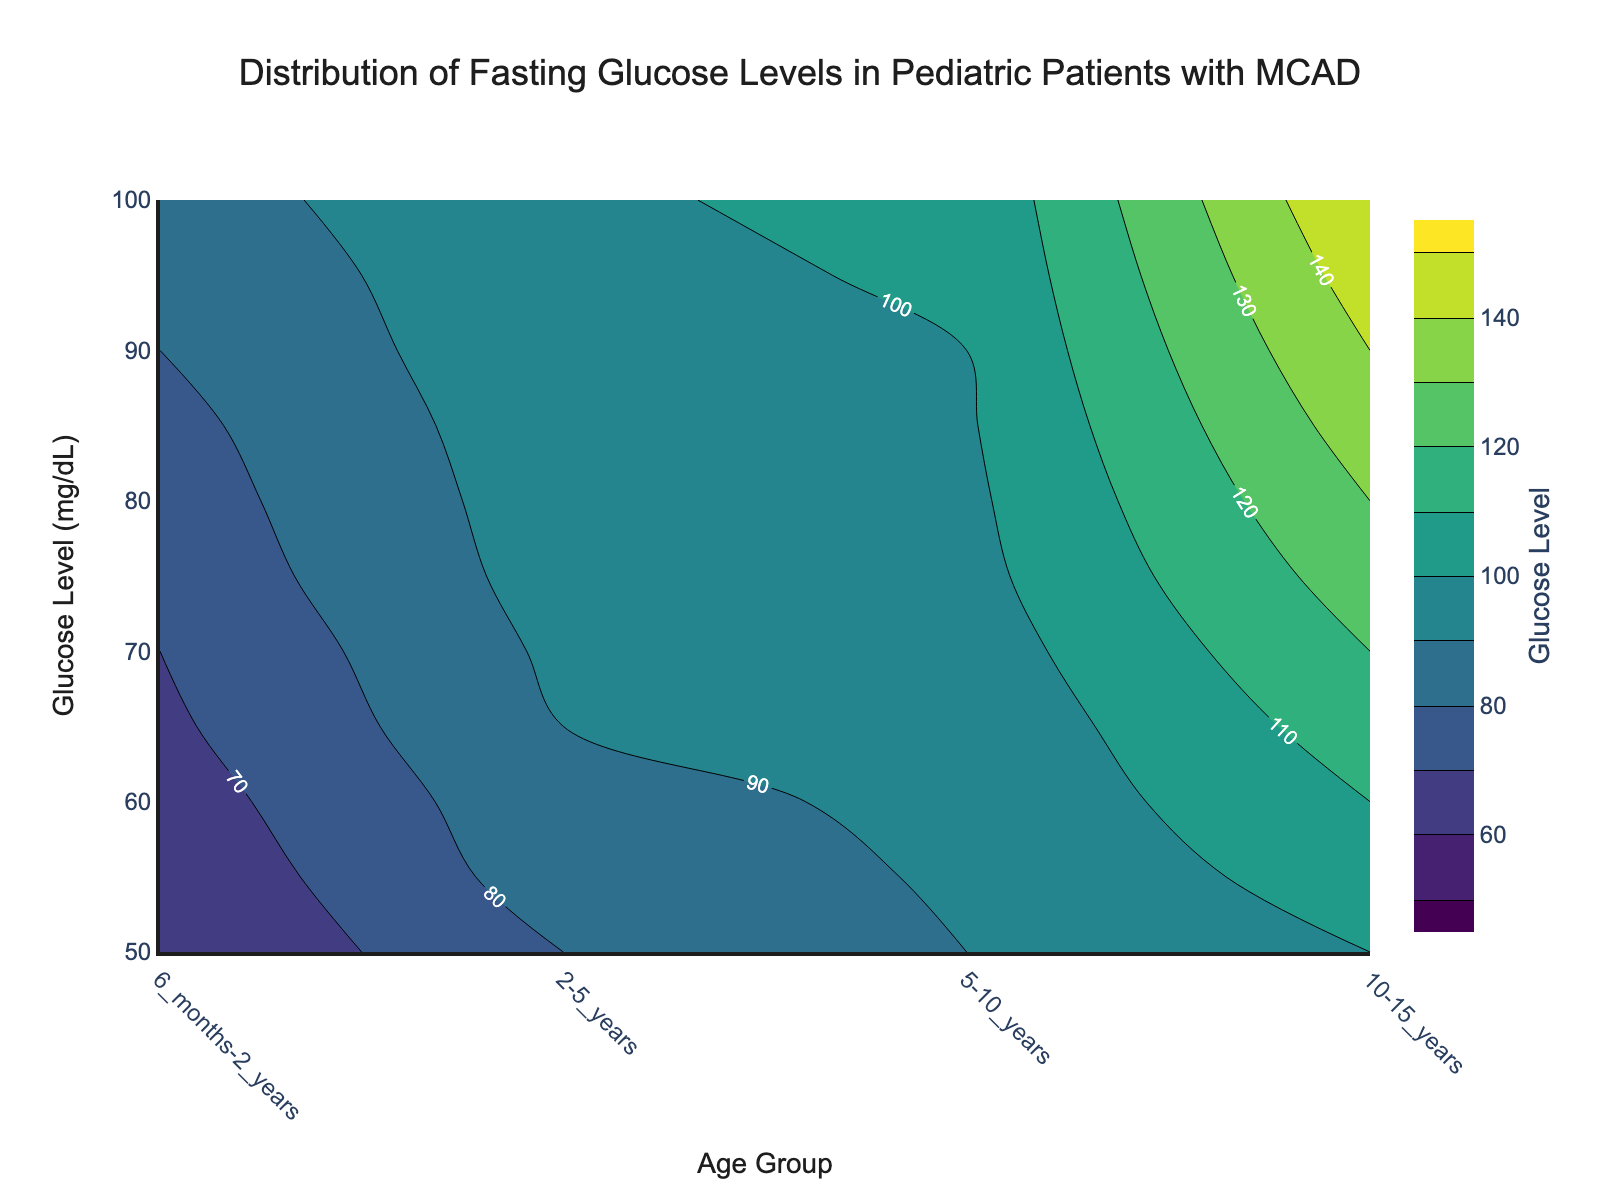What is the title of the figure? The title of the figure is displayed at the top and reads, "Distribution of Fasting Glucose Levels in Pediatric Patients with MCAD".
Answer: Distribution of Fasting Glucose Levels in Pediatric Patients with MCAD What color scale is used in the contour plot? The plot uses the 'Viridis' color scale, which ranges from dark purple to yellow-green.
Answer: Viridis Which age group shows the highest fasting glucose levels? Look at the contour lines and the color intensity across the age groups. The darkest yellowish-green indicates the highest glucose levels, which appears in the "10-15 years" age group.
Answer: 10-15 years What is the range of the fasting glucose levels plotted on the y-axis? The y-axis shows the glucose levels. It starts at 50 mg/dL and goes up to 150 mg/dL.
Answer: 50 to 150 mg/dL At what age group does the fasting glucose level first reach 100 mg/dL? Observe the contour lines and their corresponding labels. The 100 mg/dL contour line starts appearing in the "2-5 years" age group.
Answer: 2-5 years How does the fasting glucose level change as the age group increases from 6 months to 15 years? Trace the contour lines from left to right. As the age group increases, the glucose levels generally increase from 50 mg/dL to 150 mg/dL.
Answer: It increases Compare the glucose levels between the "6 months-2 years" and "5-10 years" age groups. Which one is higher and by how much? Identify the contour lines for both age groups. The "5-10 years" age group has higher glucose levels, ranging from 80 mg/dL to 99 mg/dL, compared to 50 mg/dL to 85 mg/dL for "6 months-2 years". The maximum difference is 99 - 85 = 14 mg/dL.
Answer: "5-10 years" is higher by up to 14 mg/dL What is the average fasting glucose level in the "10-15 years" age group based on the contour labels? Identify the glucose levels in the "10-15 years" age group, which are from 100 mg/dL to 150 mg/dL. The midpoint value is (100 + 150) / 2 = 125 mg/dL.
Answer: 125 mg/dL What does the contour plot reveal about the trend in fasting glucose levels as children with MCAD age? The contour lines and colors indicate that fasting glucose levels increase with age. The oldest group ("10-15 years") shows the highest levels, reaching up to 150 mg/dL.
Answer: Glucose levels increase with age 